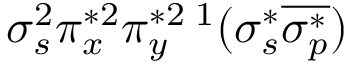Convert formula to latex. <formula><loc_0><loc_0><loc_500><loc_500>\sigma _ { s } ^ { 2 } \pi _ { x } ^ { * 2 } \pi _ { y } ^ { * 2 \, ^ { 1 } ( \sigma _ { s } ^ { * } \overline { { \sigma _ { p } ^ { * } } } )</formula> 